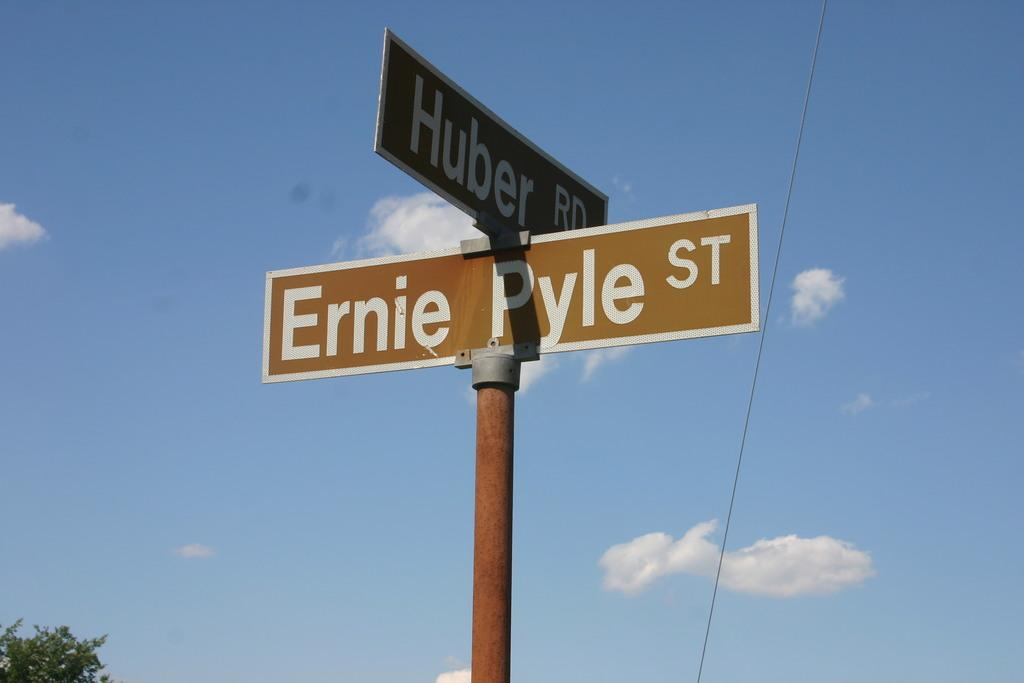Provide a one-sentence caption for the provided image. brown intersection street sign at Ernie Pyle St and Huber Rd. 